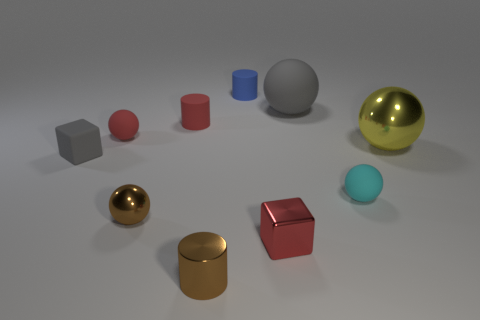Is the shape of the gray rubber object to the right of the small blue matte cylinder the same as the red object in front of the gray matte cube?
Your answer should be compact. No. How many other objects are there of the same color as the rubber cube?
Make the answer very short. 1. There is a large ball left of the tiny rubber sphere that is in front of the yellow object behind the tiny shiny cylinder; what is its material?
Provide a short and direct response. Rubber. There is a small cylinder right of the small cylinder that is in front of the small gray rubber block; what is it made of?
Make the answer very short. Rubber. Is the number of large yellow objects in front of the big metal object less than the number of green metal cylinders?
Offer a very short reply. No. The tiny red object behind the tiny red sphere has what shape?
Make the answer very short. Cylinder. Is the size of the cyan sphere the same as the gray object behind the yellow shiny ball?
Provide a short and direct response. No. Are there any tiny blue cylinders that have the same material as the small red block?
Offer a very short reply. No. How many spheres are red matte objects or large yellow objects?
Offer a very short reply. 2. There is a cyan matte sphere that is behind the small brown cylinder; are there any small blue objects that are left of it?
Ensure brevity in your answer.  Yes. 